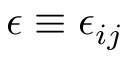Convert formula to latex. <formula><loc_0><loc_0><loc_500><loc_500>\epsilon \equiv \epsilon _ { i j }</formula> 